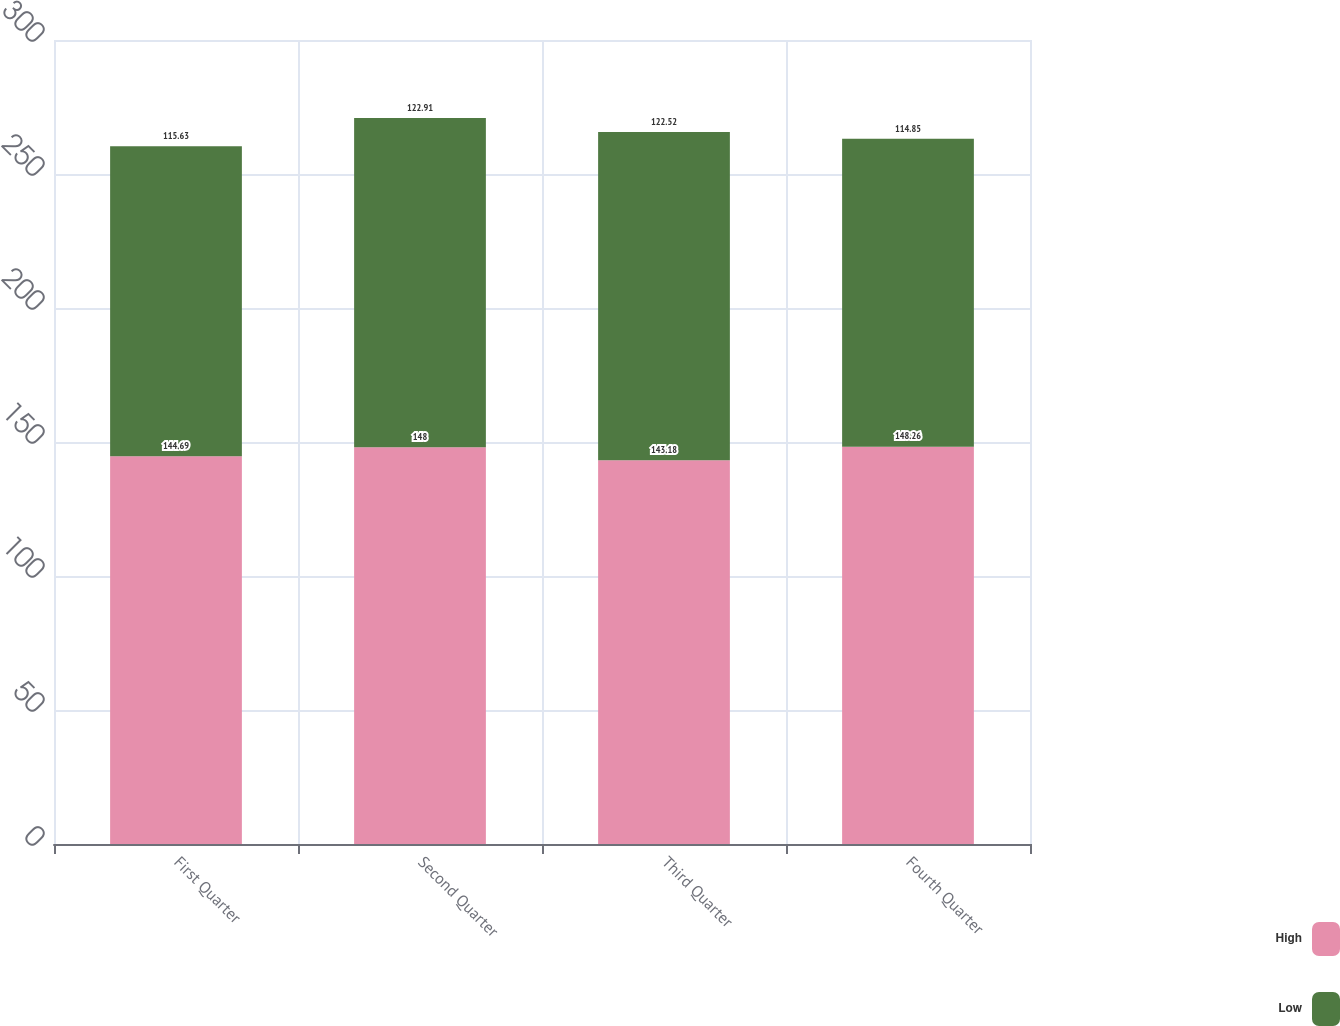<chart> <loc_0><loc_0><loc_500><loc_500><stacked_bar_chart><ecel><fcel>First Quarter<fcel>Second Quarter<fcel>Third Quarter<fcel>Fourth Quarter<nl><fcel>High<fcel>144.69<fcel>148<fcel>143.18<fcel>148.26<nl><fcel>Low<fcel>115.63<fcel>122.91<fcel>122.52<fcel>114.85<nl></chart> 